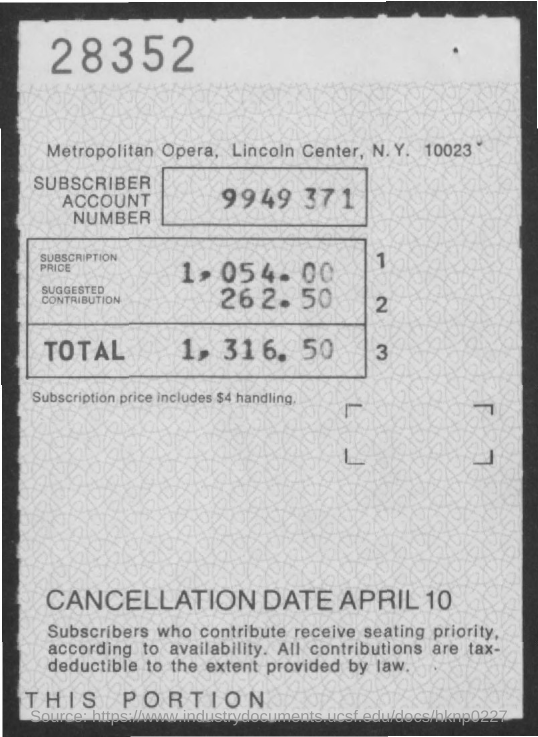What is the Suscriber Account Number?
Offer a very short reply. 9949 371. What is the Subscription Price?
Offer a terse response. 1,054.00. What is the Suggested contribution?
Give a very brief answer. 262.50. What is the Total?
Keep it short and to the point. 1,316.50. 